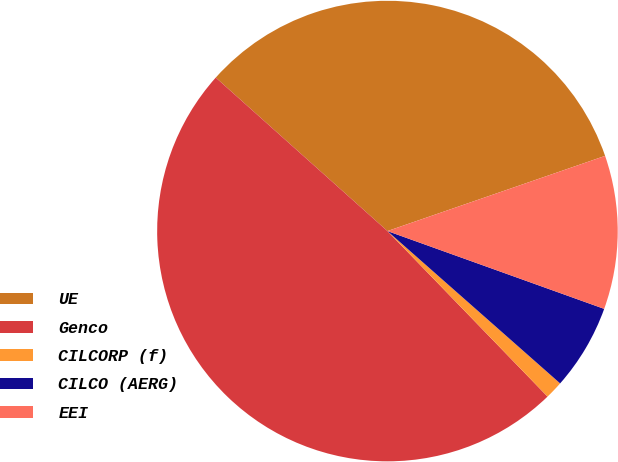Convert chart to OTSL. <chart><loc_0><loc_0><loc_500><loc_500><pie_chart><fcel>UE<fcel>Genco<fcel>CILCORP (f)<fcel>CILCO (AERG)<fcel>EEI<nl><fcel>33.1%<fcel>48.85%<fcel>1.26%<fcel>6.02%<fcel>10.78%<nl></chart> 